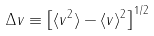<formula> <loc_0><loc_0><loc_500><loc_500>\Delta v \equiv \left [ \langle v ^ { 2 } \rangle - \langle v \rangle ^ { 2 } \right ] ^ { 1 / 2 }</formula> 